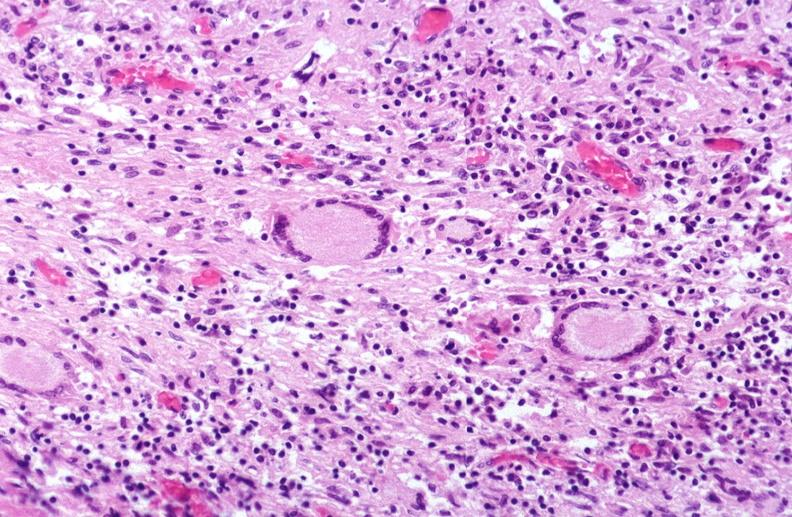does ap view show lung, mycobacterium tuberculosis, granulomas and giant cells?
Answer the question using a single word or phrase. No 